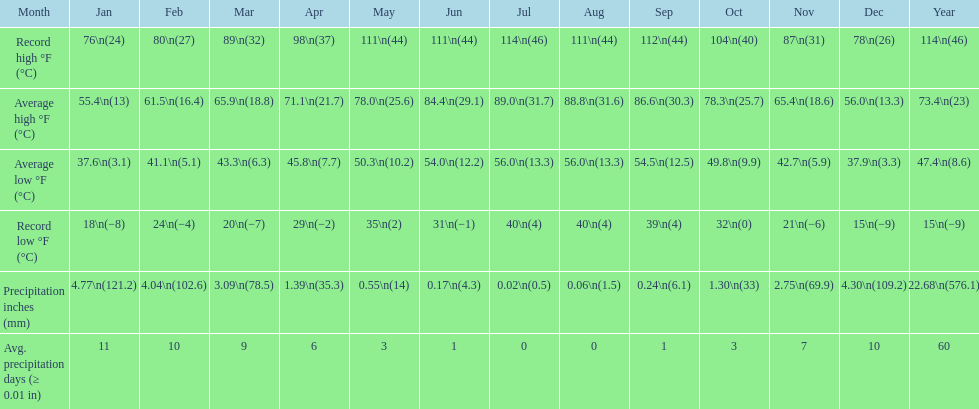Which month had an average high of 89.0 degrees and an average low of 56.0 degrees? July. 